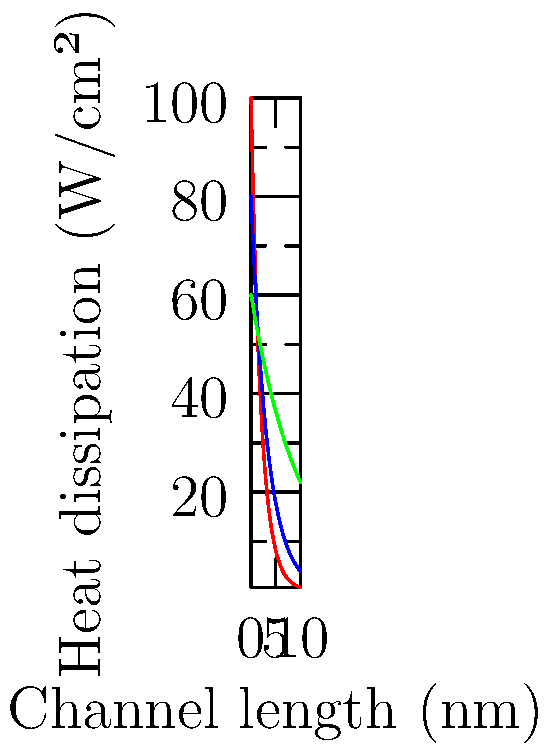Based on the graph showing heat dissipation in nanoscale transistors with varying geometries, which transistor design exhibits the best heat dissipation characteristics for channel lengths below 5 nm, and why is this significant for future nanoelectronics? To answer this question, we need to analyze the heat dissipation characteristics of the three transistor designs shown in the graph:

1. Planar (red line)
2. FinFET (blue line)
3. Gate-all-around (green line)

Step 1: Examine the heat dissipation trends
- All three designs show decreasing heat dissipation as channel length increases.
- The planar design has the highest initial heat dissipation but decreases rapidly.
- The FinFET design starts lower than planar but decreases less rapidly.
- The gate-all-around design has the lowest initial heat dissipation and decreases the least rapidly.

Step 2: Focus on channel lengths below 5 nm
For channel lengths below 5 nm, the gate-all-around design (green line) shows the lowest heat dissipation among the three designs.

Step 3: Understand the significance
Lower heat dissipation is crucial for nanoelectronics because:
a) It allows for higher transistor density without overheating.
b) It reduces power consumption, improving energy efficiency.
c) It enhances device reliability and longevity.
d) It enables the continued scaling of transistors to smaller dimensions.

Step 4: Consider the implications for future nanoelectronics
The gate-all-around design's superior heat dissipation characteristics at extremely small channel lengths (below 5 nm) make it a promising candidate for future nanoelectronic devices. This design could potentially enable the continuation of Moore's Law by allowing further miniaturization of transistors while managing heat dissipation effectively.
Answer: Gate-all-around design; enables continued transistor scaling with better heat management. 